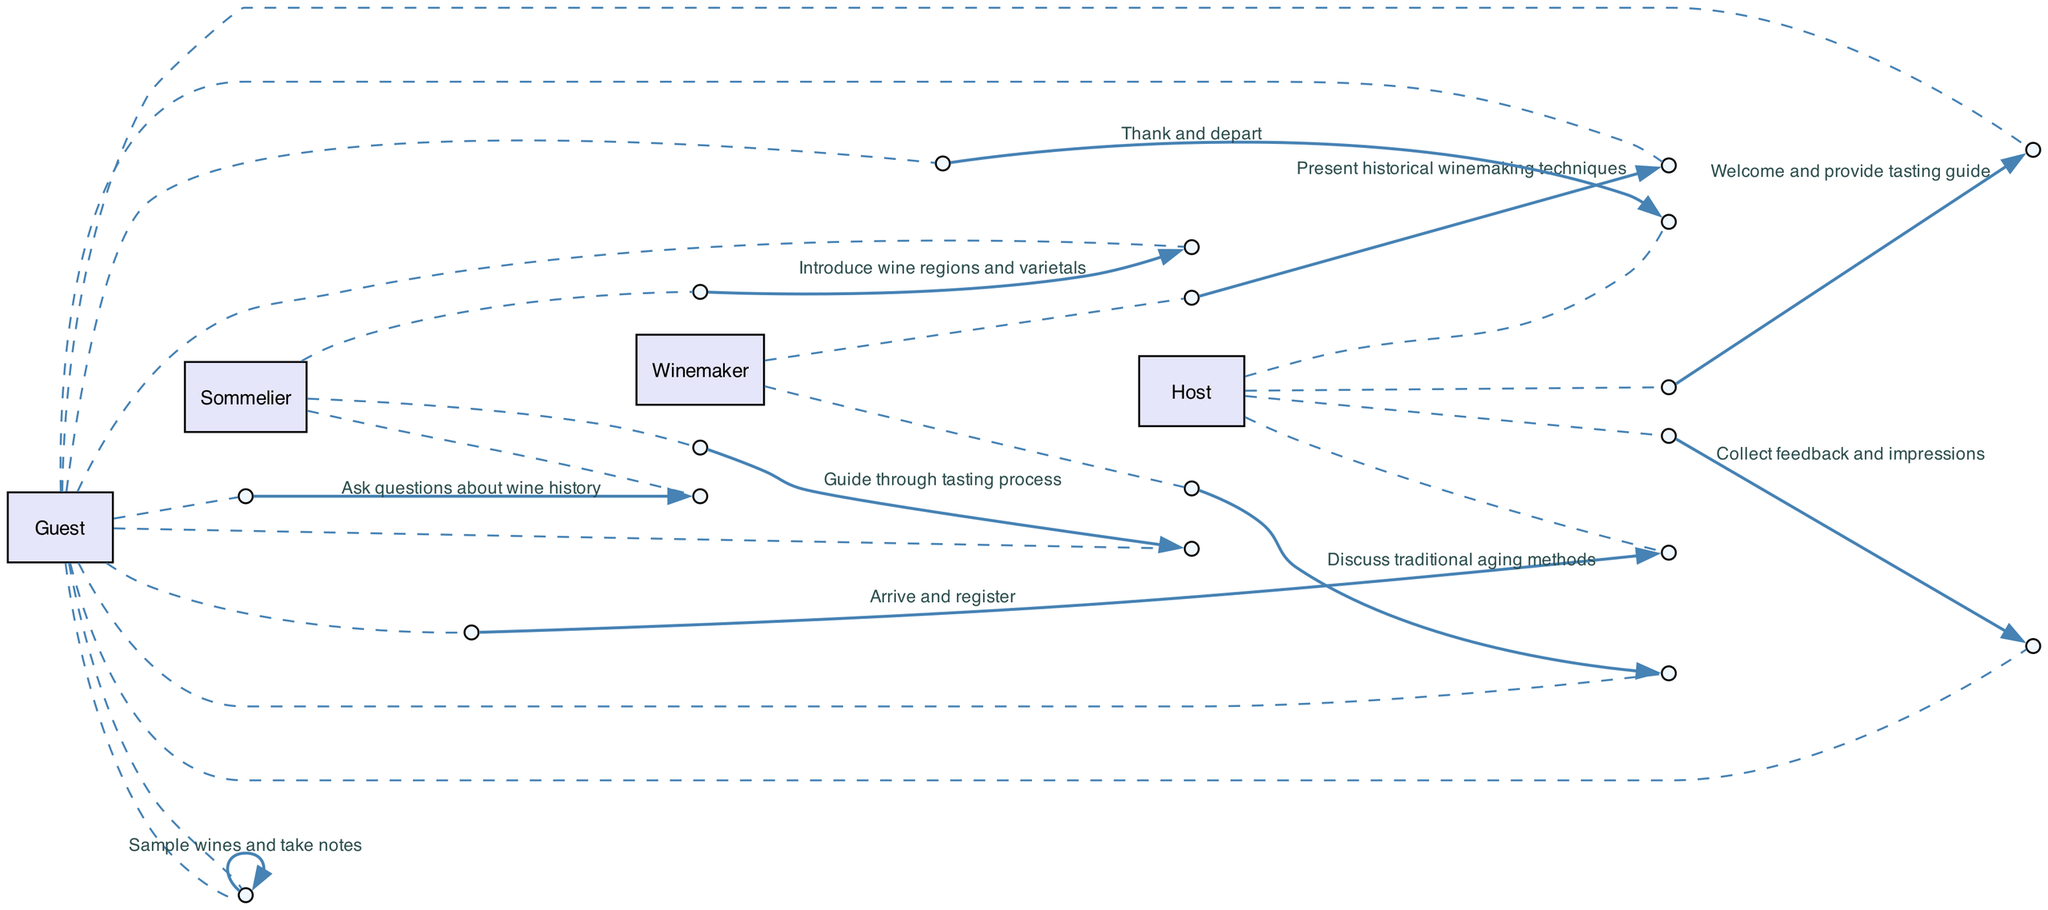What is the first action performed by the Guest? The first action listed in the sequence diagram is "Arrive and register" performed by the Guest. This is the starting point of the sequence of events in the wine tasting event.
Answer: Arrive and register How many actors are involved in the wine tasting event sequence? The diagram lists four actors: Guest, Sommelier, Winemaker, and Host. By simply counting the distinct names, we can confirm the number of actors.
Answer: 4 Which actor provides the tasting guide to the Guest? According to the sequence, the Host is responsible for welcoming the Guest and providing the tasting guide. This is indicated in the second event of the sequence.
Answer: Host What action does the Winemaker perform after introducing historical techniques? Following the presentation of historical winemaking techniques, the Winemaker discusses traditional aging methods with the Guest. This shows a sequence of events involving the Winemaker and the Guest.
Answer: Discuss traditional aging methods How many times does the Guest interact with the Sommelier? The Guest interacts with the Sommelier twice in the sequence: first, when the Sommelier introduces wine regions and varietals, and second, when the Guest asks questions about wine history. Counting these interactions shows the total engagements.
Answer: 2 What does the Host collect from the Guests at the end of the event? At the end of the wine tasting event, the Host collects feedback and impressions from the Guests. This is the second-to-last action listed in the sequence.
Answer: Feedback and impressions What is the final action taken by the Guest in the sequence? The final action taken by the Guest is to "Thank and depart," which concludes their participation in the event. This is explicitly stated as the last event in the sequence.
Answer: Thank and depart Which action directly follows the introduction of wine regions by the Sommelier? After the Sommelier introduces wine regions and varietals to the Guest, the next action involves the Winemaker presenting historical winemaking techniques. This shows a flow from the Sommelier's action to that of the Winemaker.
Answer: Present historical winemaking techniques How does the Guest engage during the tasting process? The sequence indicates that the Guest samples wines and takes notes during this process, which is a crucial part of the wine tasting experience. This action reflects the engagement level of the Guest in the event.
Answer: Sample wines and take notes 